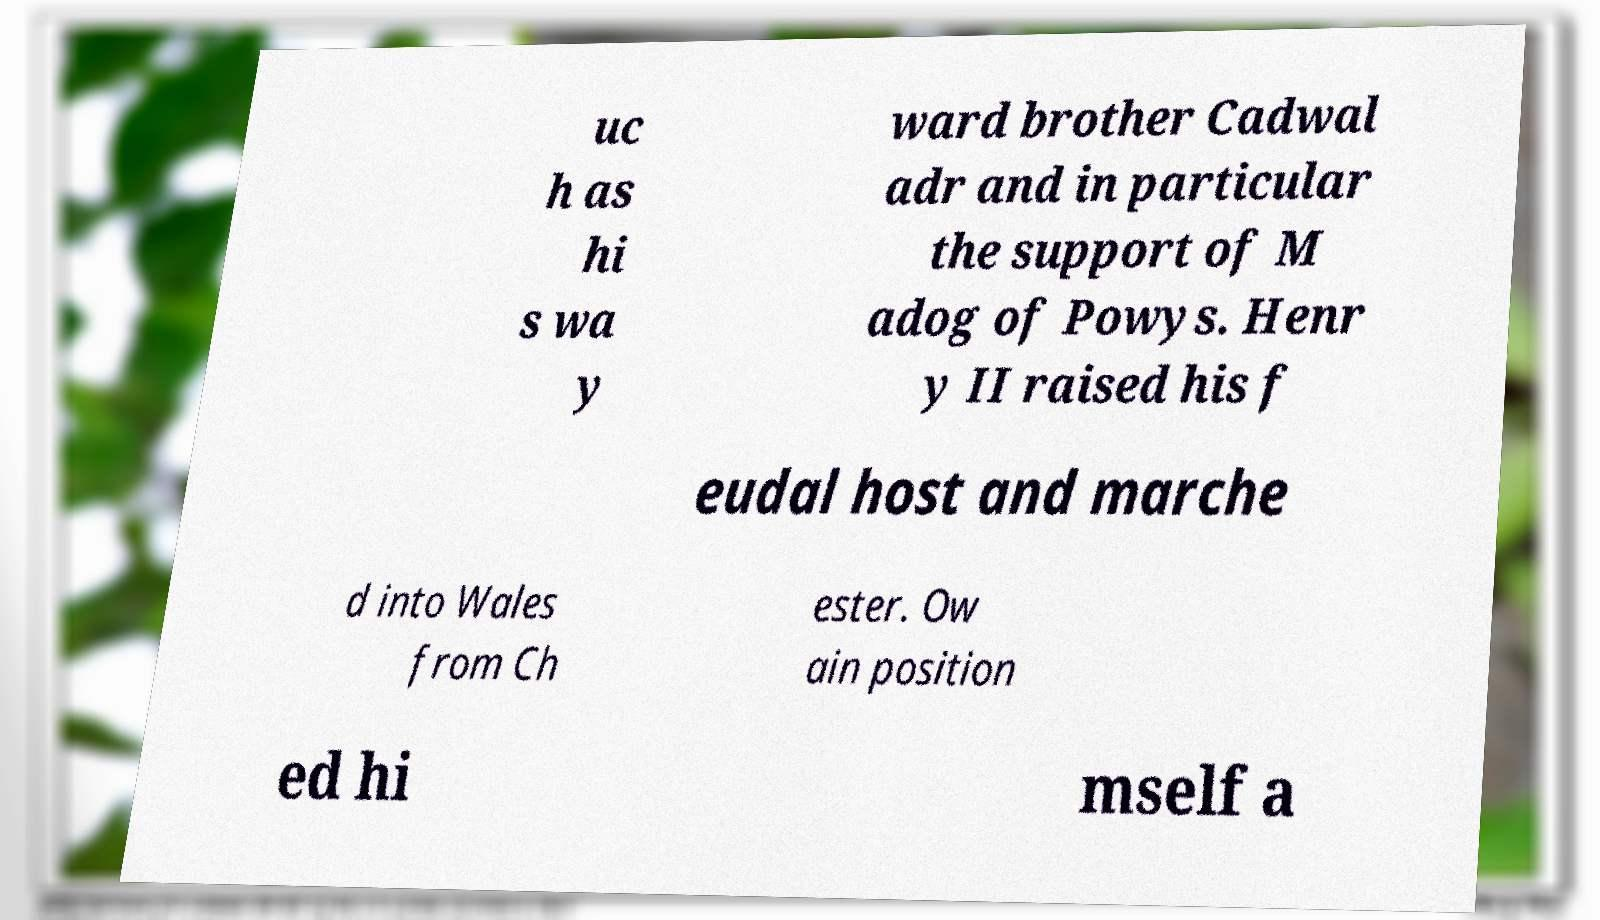Could you assist in decoding the text presented in this image and type it out clearly? uc h as hi s wa y ward brother Cadwal adr and in particular the support of M adog of Powys. Henr y II raised his f eudal host and marche d into Wales from Ch ester. Ow ain position ed hi mself a 